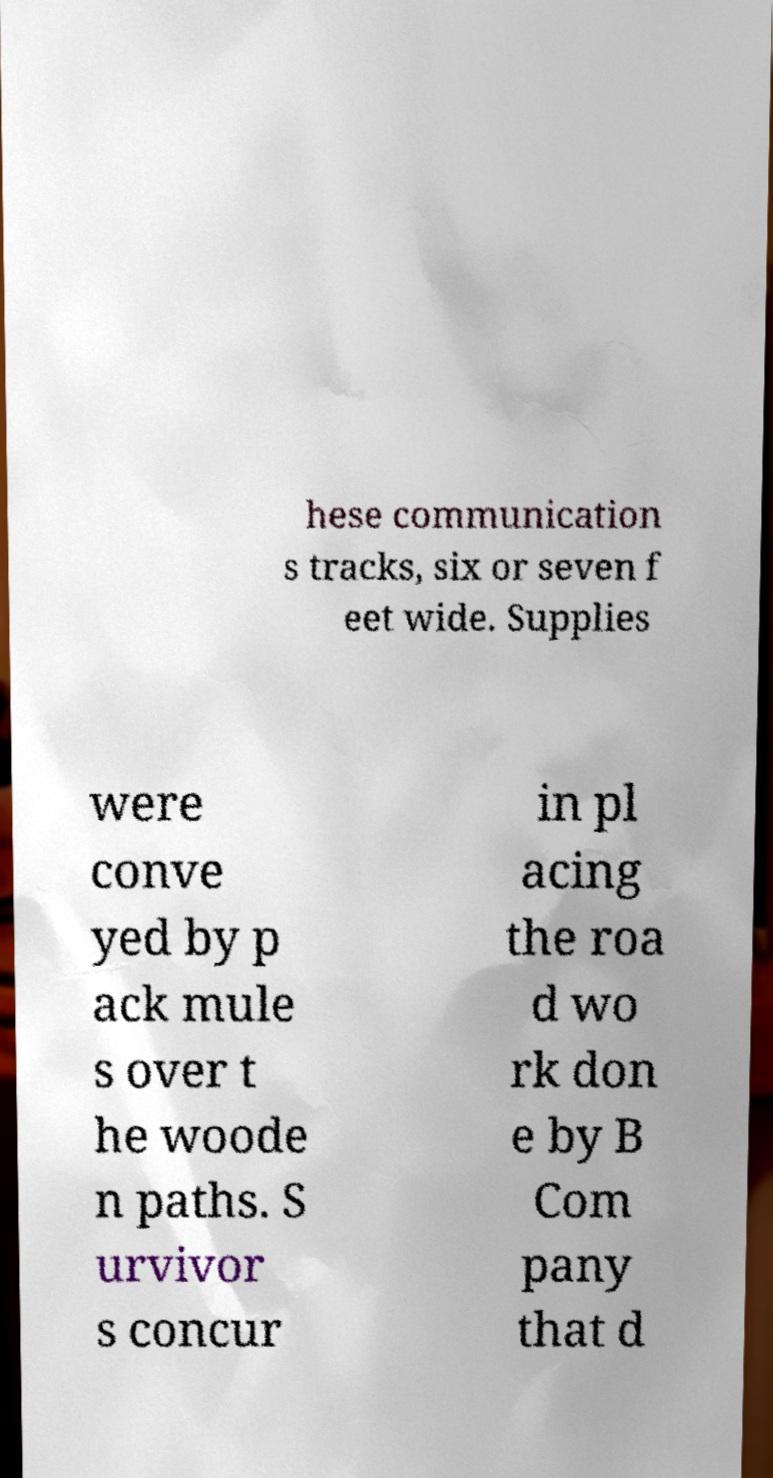Can you read and provide the text displayed in the image?This photo seems to have some interesting text. Can you extract and type it out for me? hese communication s tracks, six or seven f eet wide. Supplies were conve yed by p ack mule s over t he woode n paths. S urvivor s concur in pl acing the roa d wo rk don e by B Com pany that d 